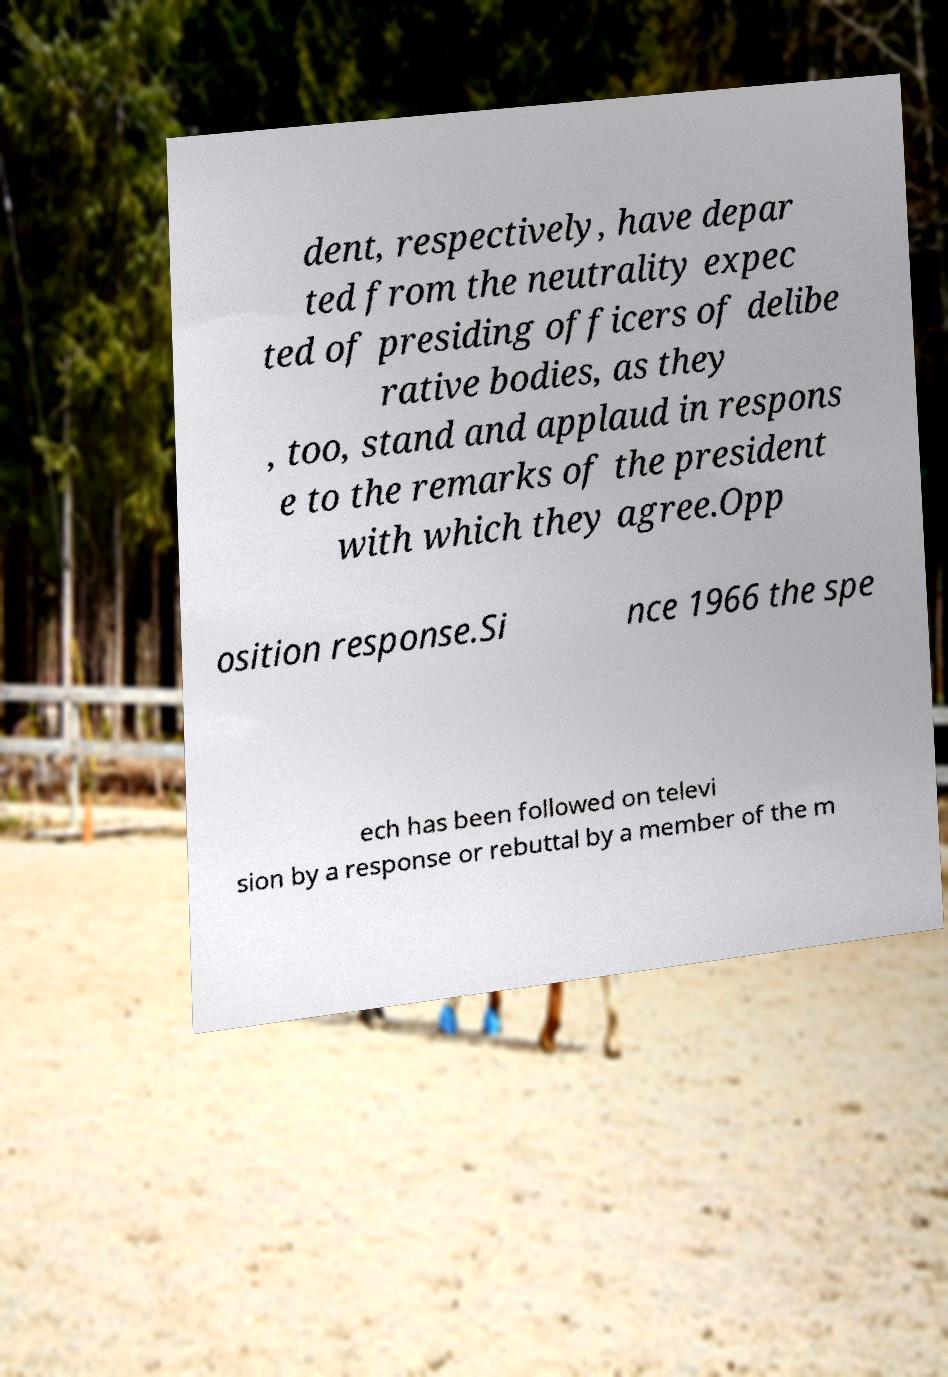Can you read and provide the text displayed in the image?This photo seems to have some interesting text. Can you extract and type it out for me? dent, respectively, have depar ted from the neutrality expec ted of presiding officers of delibe rative bodies, as they , too, stand and applaud in respons e to the remarks of the president with which they agree.Opp osition response.Si nce 1966 the spe ech has been followed on televi sion by a response or rebuttal by a member of the m 